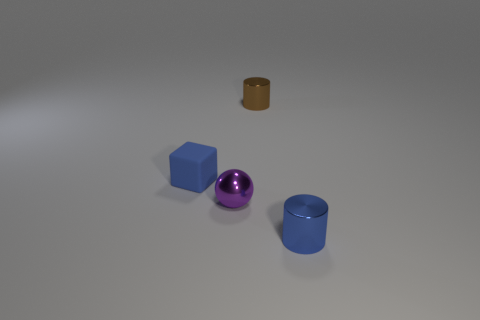Is there anything else that is made of the same material as the purple ball?
Provide a short and direct response. Yes. The object that is the same color as the small cube is what size?
Offer a terse response. Small. How many brown metal things have the same shape as the tiny blue metal object?
Ensure brevity in your answer.  1. What material is the blue object that is right of the matte cube?
Your response must be concise. Metal. How big is the metallic object that is to the left of the tiny cylinder behind the tiny cylinder that is in front of the tiny blue cube?
Your response must be concise. Small. Is the tiny thing that is in front of the small purple metal thing made of the same material as the purple sphere that is in front of the brown cylinder?
Ensure brevity in your answer.  Yes. How many other things are the same color as the cube?
Keep it short and to the point. 1. What number of objects are either small things in front of the small brown metallic cylinder or tiny metal objects behind the tiny blue cylinder?
Provide a short and direct response. 4. What is the size of the cylinder left of the small metallic cylinder in front of the matte cube?
Provide a short and direct response. Small. The purple ball has what size?
Your answer should be compact. Small. 